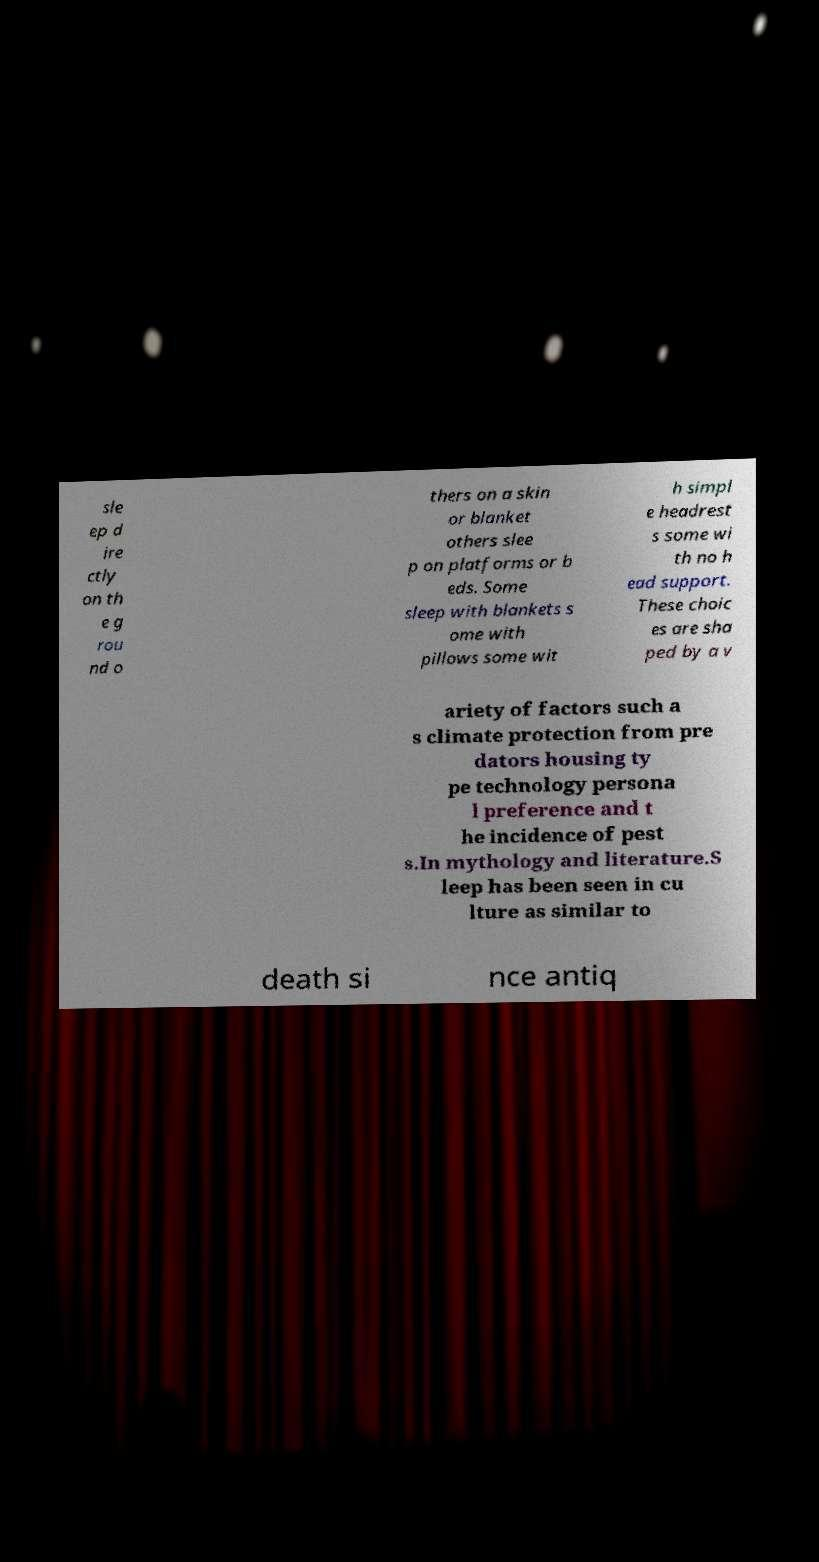Please read and relay the text visible in this image. What does it say? sle ep d ire ctly on th e g rou nd o thers on a skin or blanket others slee p on platforms or b eds. Some sleep with blankets s ome with pillows some wit h simpl e headrest s some wi th no h ead support. These choic es are sha ped by a v ariety of factors such a s climate protection from pre dators housing ty pe technology persona l preference and t he incidence of pest s.In mythology and literature.S leep has been seen in cu lture as similar to death si nce antiq 